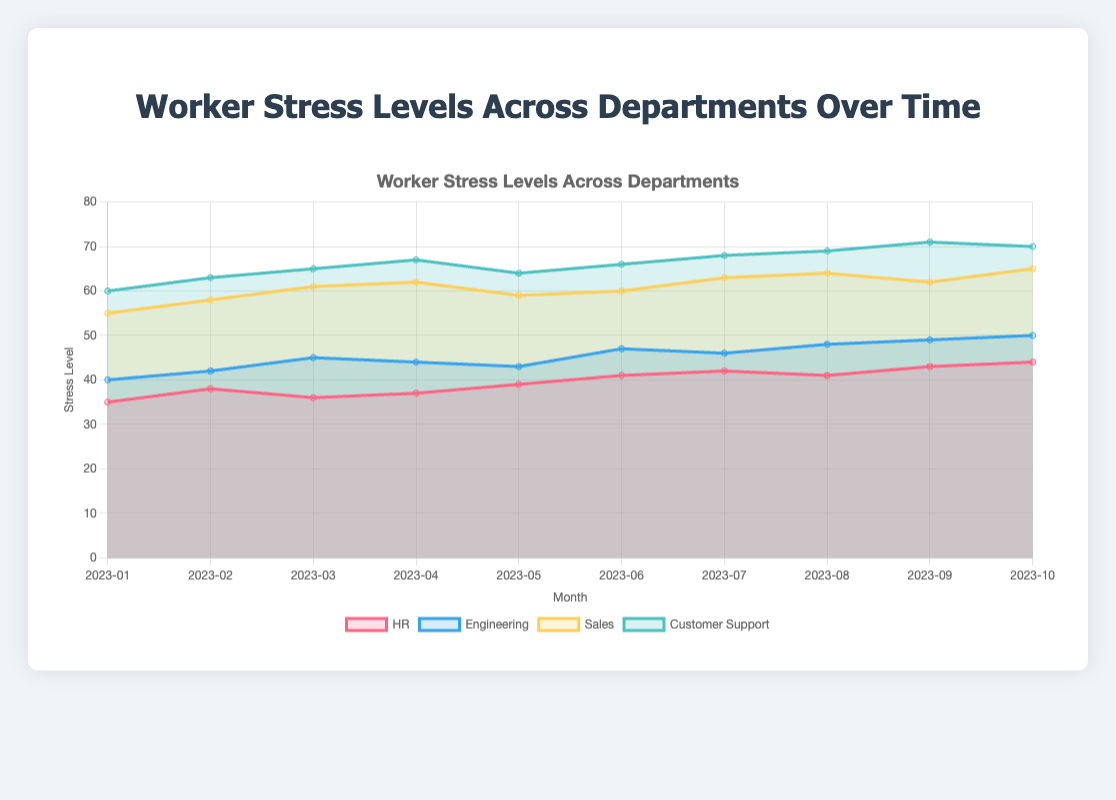What is the title of the chart? The title of the chart is located at the top-center and it provides a summary of the visualized data.
Answer: Worker Stress Levels Across Departments Over Time Which department had the highest stress level in January 2023? By examining the data points for each department in January 2023, Customer Support had the highest value.
Answer: Customer Support How has the stress level in the Engineering department changed from January to October 2023? Observing the data points for the Engineering department from January to October shows a consistent increase in stress levels over time.
Answer: Increased Which month had the lowest stress level for the Sales department? Looking at the Sales department's stress levels over all months, January 2023 has the lowest value.
Answer: January 2023 What is the average stress level for the HR department over the period shown? Summing up the stress levels for HR from January to October (35+38+36+37+39+41+42+41+43+44) results in 396. Dividing by the number of months, which is 10, gives the average.
Answer: 39.6 What is the difference in stress levels between the Sales and HR departments in June 2023? Subtracting the HR stress level in June 2023 (41) from the Sales stress level in June 2023 (60) gives the difference.
Answer: 19 Compare the stress levels in August 2023 for HR and Customer Support departments. Which one is higher? By looking at the stress levels in August 2023, HR is 41 and Customer Support is 69. The higher value is for Customer Support.
Answer: Customer Support What trend do you observe in the Customer Support department's stress levels from January to October 2023? Observing the data points for Customer Support from January to October shows a consistent upward trend.
Answer: Increasing Which department had the least fluctuation in stress levels over the period shown? By comparing the range (difference between minimum and maximum) of stress levels among the departments, Engineering shows the least fluctuation (40 to 50, a range of 10).
Answer: Engineering Between which consecutive months did the HR department experience the largest increase in stress level? Calculating the differences between consecutive months for HR, the largest increase is between May (39) and June (41), a difference of 2.
Answer: May to June 